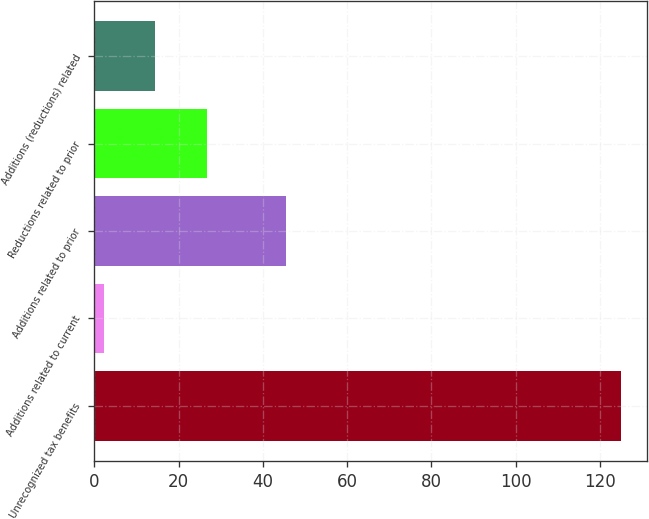Convert chart to OTSL. <chart><loc_0><loc_0><loc_500><loc_500><bar_chart><fcel>Unrecognized tax benefits<fcel>Additions related to current<fcel>Additions related to prior<fcel>Reductions related to prior<fcel>Additions (reductions) related<nl><fcel>125<fcel>2.2<fcel>45.6<fcel>26.76<fcel>14.48<nl></chart> 